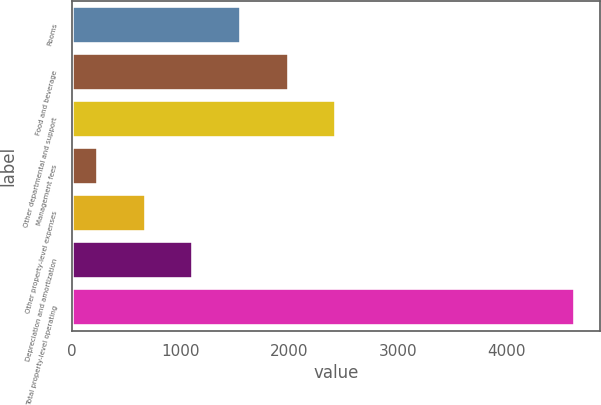Convert chart to OTSL. <chart><loc_0><loc_0><loc_500><loc_500><bar_chart><fcel>Rooms<fcel>Food and beverage<fcel>Other departmental and support<fcel>Management fees<fcel>Other property-level expenses<fcel>Depreciation and amortization<fcel>Total property-level operating<nl><fcel>1555.4<fcel>1994.2<fcel>2433<fcel>239<fcel>677.8<fcel>1116.6<fcel>4627<nl></chart> 